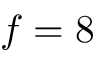<formula> <loc_0><loc_0><loc_500><loc_500>f = 8</formula> 